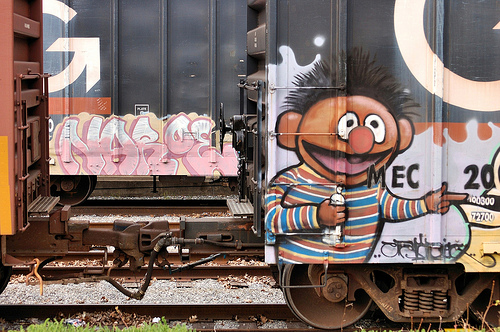<image>
Is there a ernie on the train? Yes. Looking at the image, I can see the ernie is positioned on top of the train, with the train providing support. 